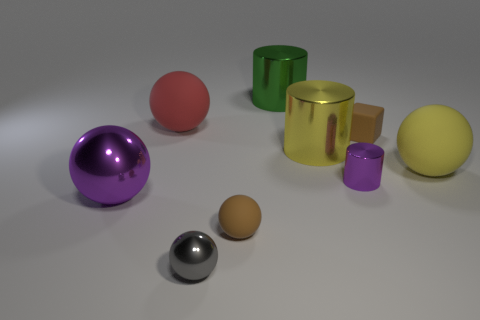What is the color of the large shiny sphere?
Your answer should be very brief. Purple. Are there any big red things behind the big green cylinder?
Your answer should be very brief. No. There is a red thing; does it have the same shape as the large metallic object in front of the yellow rubber ball?
Your answer should be compact. Yes. How many other objects are there of the same material as the small purple thing?
Offer a terse response. 4. The shiny thing on the left side of the tiny sphere that is in front of the brown object in front of the yellow shiny cylinder is what color?
Keep it short and to the point. Purple. The large matte thing to the left of the rubber sphere right of the tiny rubber ball is what shape?
Provide a short and direct response. Sphere. Is the number of tiny purple cylinders on the right side of the big green metal cylinder greater than the number of small gray objects?
Keep it short and to the point. No. There is a yellow thing right of the purple cylinder; is it the same shape as the small purple object?
Offer a terse response. No. Are there any big blue metallic things of the same shape as the large yellow shiny object?
Your answer should be compact. No. How many things are either yellow objects that are on the left side of the tiny block or shiny cylinders?
Your answer should be compact. 3. 